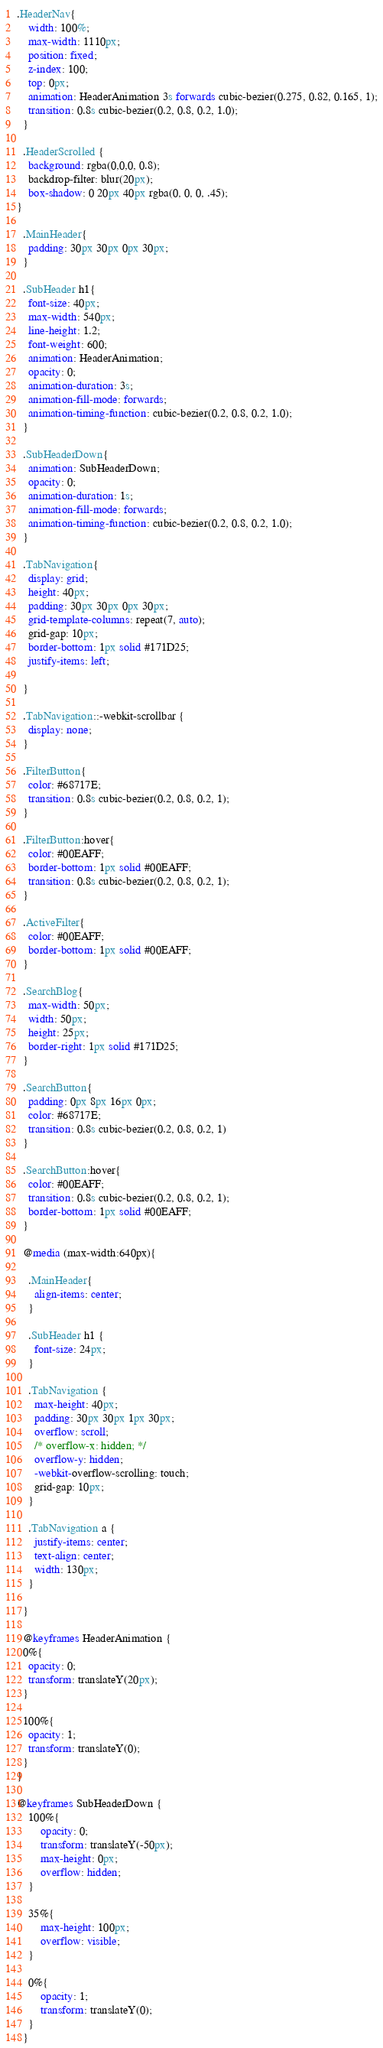<code> <loc_0><loc_0><loc_500><loc_500><_CSS_>
.HeaderNav{
    width: 100%;
    max-width: 1110px;
    position: fixed;
    z-index: 100;
    top: 0px;
    animation: HeaderAnimation 3s forwards cubic-bezier(0.275, 0.82, 0.165, 1);
    transition: 0.8s cubic-bezier(0.2, 0.8, 0.2, 1.0);
  }
  
  .HeaderScrolled {
    background: rgba(0,0,0, 0.8);
    backdrop-filter: blur(20px);
    box-shadow: 0 20px 40px rgba(0, 0, 0, .45);
}

  .MainHeader{
    padding: 30px 30px 0px 30px;
  } 

  .SubHeader h1{
    font-size: 40px;
    max-width: 540px;
    line-height: 1.2;
    font-weight: 600;
    animation: HeaderAnimation;
    opacity: 0;
    animation-duration: 3s;
    animation-fill-mode: forwards;
    animation-timing-function: cubic-bezier(0.2, 0.8, 0.2, 1.0);
  }

  .SubHeaderDown{
    animation: SubHeaderDown;
    opacity: 0;
    animation-duration: 1s;
    animation-fill-mode: forwards;
    animation-timing-function: cubic-bezier(0.2, 0.8, 0.2, 1.0);
  }
  
  .TabNavigation{
    display: grid;
    height: 40px;
    padding: 30px 30px 0px 30px;
    grid-template-columns: repeat(7, auto);
    grid-gap: 10px;
    border-bottom: 1px solid #171D25;
    justify-items: left;
    
  }

  .TabNavigation::-webkit-scrollbar {
    display: none;
  }

  .FilterButton{
    color: #68717E;
    transition: 0.8s cubic-bezier(0.2, 0.8, 0.2, 1);
  }
  
  .FilterButton:hover{
    color: #00EAFF;
    border-bottom: 1px solid #00EAFF;
    transition: 0.8s cubic-bezier(0.2, 0.8, 0.2, 1);
  }

  .ActiveFilter{
    color: #00EAFF;
    border-bottom: 1px solid #00EAFF;
  }

  .SearchBlog{
    max-width: 50px;
    width: 50px;
    height: 25px;
    border-right: 1px solid #171D25;
  }

  .SearchButton{
    padding: 0px 8px 16px 0px;
    color: #68717E;
    transition: 0.8s cubic-bezier(0.2, 0.8, 0.2, 1)
  }

  .SearchButton:hover{
    color: #00EAFF;
    transition: 0.8s cubic-bezier(0.2, 0.8, 0.2, 1);
    border-bottom: 1px solid #00EAFF;
  }

  @media (max-width:640px){

    .MainHeader{
      align-items: center;
    }

    .SubHeader h1 {
      font-size: 24px;
    }

    .TabNavigation {
      max-height: 40px;
      padding: 30px 30px 1px 30px;
      overflow: scroll;
      /* overflow-x: hidden; */
      overflow-y: hidden;
      -webkit-overflow-scrolling: touch;
      grid-gap: 10px;
    }

    .TabNavigation a {
      justify-items: center;
      text-align: center;
      width: 130px;
    }

  }

  @keyframes HeaderAnimation {
  0%{
    opacity: 0;
    transform: translateY(20px);
  }

  100%{
    opacity: 1;
    transform: translateY(0);
  }
}

@keyframes SubHeaderDown {
    100%{
        opacity: 0;
        transform: translateY(-50px);
        max-height: 0px;
        overflow: hidden;
    }
  
    35%{
        max-height: 100px;
        overflow: visible;
    }

    0%{
        opacity: 1;
        transform: translateY(0); 
    }
  }
</code> 